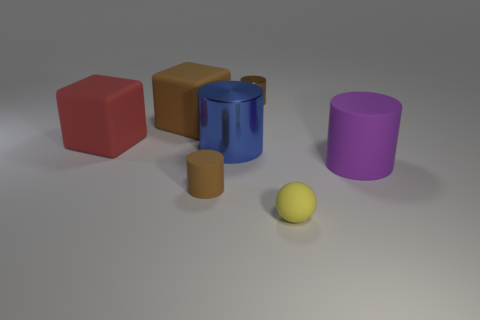Does the tiny metallic cylinder have the same color as the small matte cylinder?
Make the answer very short. Yes. What shape is the tiny metal thing that is the same color as the small matte cylinder?
Provide a succinct answer. Cylinder. Are there any matte cylinders that have the same color as the tiny metal cylinder?
Your answer should be very brief. Yes. Are there the same number of metal cylinders that are right of the big purple cylinder and brown rubber things behind the big red cube?
Offer a terse response. No. There is a yellow object; is its shape the same as the tiny matte thing that is behind the small sphere?
Provide a succinct answer. No. How many other objects are there of the same material as the large blue cylinder?
Ensure brevity in your answer.  1. Are there any big brown things behind the red cube?
Give a very brief answer. Yes. There is a yellow thing; does it have the same size as the rubber cylinder that is left of the sphere?
Keep it short and to the point. Yes. There is a rubber cylinder that is behind the brown cylinder that is in front of the large rubber cylinder; what color is it?
Ensure brevity in your answer.  Purple. Do the yellow object and the brown block have the same size?
Give a very brief answer. No. 